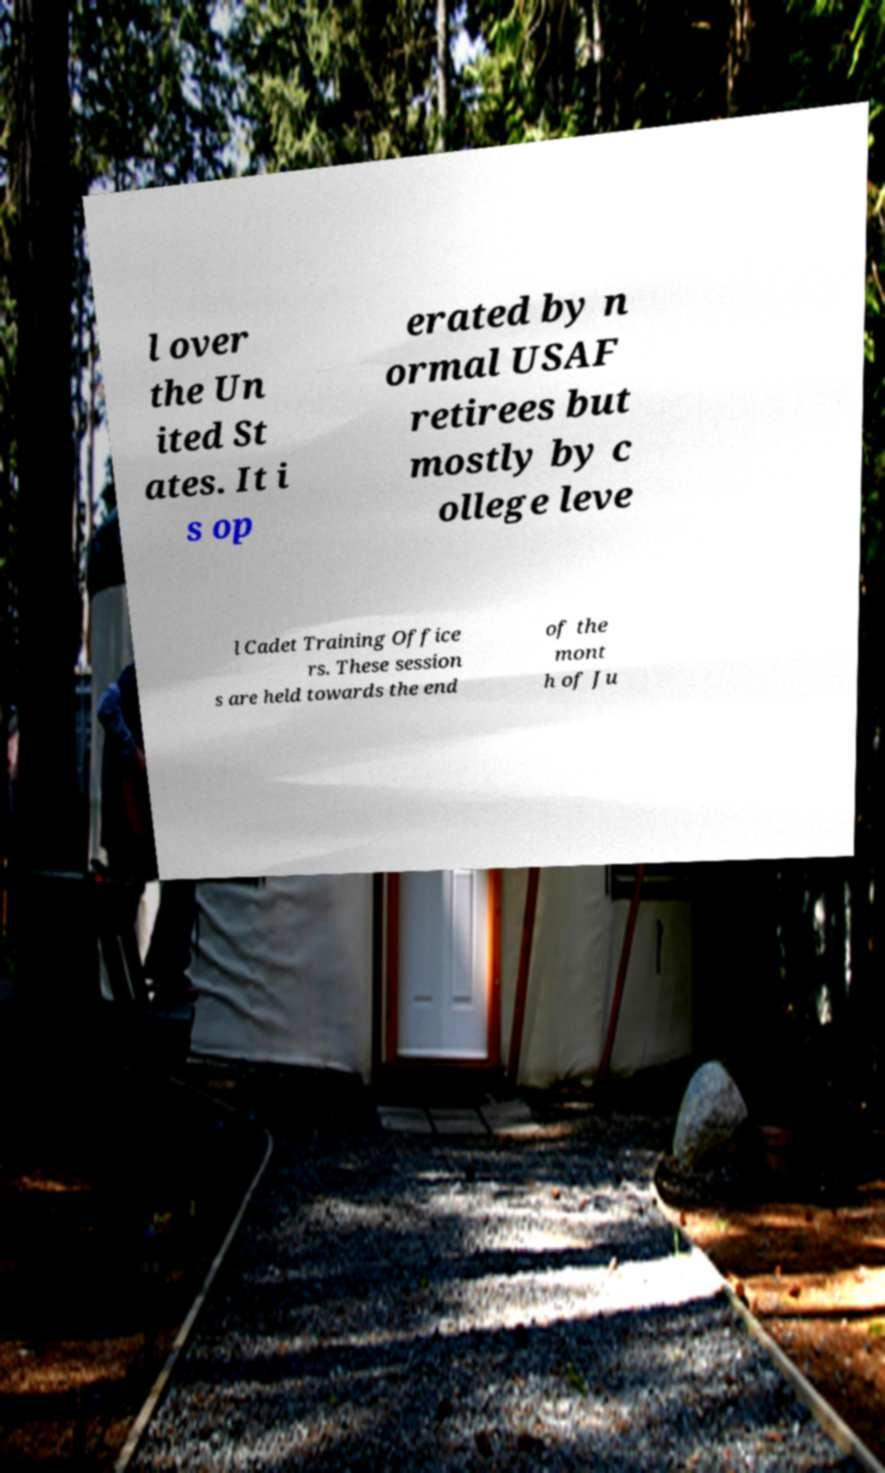Please read and relay the text visible in this image. What does it say? l over the Un ited St ates. It i s op erated by n ormal USAF retirees but mostly by c ollege leve l Cadet Training Office rs. These session s are held towards the end of the mont h of Ju 